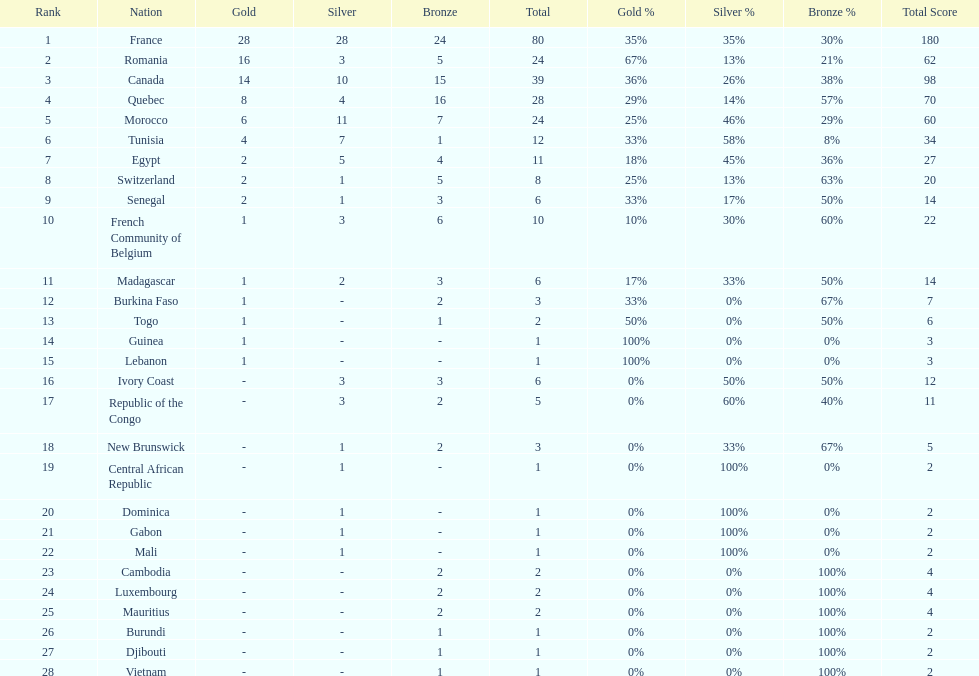Who placed in first according to medals? France. Would you mind parsing the complete table? {'header': ['Rank', 'Nation', 'Gold', 'Silver', 'Bronze', 'Total', 'Gold %', 'Silver %', 'Bronze %', 'Total Score'], 'rows': [['1', 'France', '28', '28', '24', '80', '35%', '35%', '30%', '180'], ['2', 'Romania', '16', '3', '5', '24', '67%', '13%', '21%', '62'], ['3', 'Canada', '14', '10', '15', '39', '36%', '26%', '38%', '98'], ['4', 'Quebec', '8', '4', '16', '28', '29%', '14%', '57%', '70'], ['5', 'Morocco', '6', '11', '7', '24', '25%', '46%', '29%', '60'], ['6', 'Tunisia', '4', '7', '1', '12', '33%', '58%', '8%', '34'], ['7', 'Egypt', '2', '5', '4', '11', '18%', '45%', '36%', '27'], ['8', 'Switzerland', '2', '1', '5', '8', '25%', '13%', '63%', '20'], ['9', 'Senegal', '2', '1', '3', '6', '33%', '17%', '50%', '14'], ['10', 'French Community of Belgium', '1', '3', '6', '10', '10%', '30%', '60%', '22'], ['11', 'Madagascar', '1', '2', '3', '6', '17%', '33%', '50%', '14'], ['12', 'Burkina Faso', '1', '-', '2', '3', '33%', '0%', '67%', '7'], ['13', 'Togo', '1', '-', '1', '2', '50%', '0%', '50%', '6'], ['14', 'Guinea', '1', '-', '-', '1', '100%', '0%', '0%', '3'], ['15', 'Lebanon', '1', '-', '-', '1', '100%', '0%', '0%', '3'], ['16', 'Ivory Coast', '-', '3', '3', '6', '0%', '50%', '50%', '12'], ['17', 'Republic of the Congo', '-', '3', '2', '5', '0%', '60%', '40%', '11'], ['18', 'New Brunswick', '-', '1', '2', '3', '0%', '33%', '67%', '5'], ['19', 'Central African Republic', '-', '1', '-', '1', '0%', '100%', '0%', '2'], ['20', 'Dominica', '-', '1', '-', '1', '0%', '100%', '0%', '2'], ['21', 'Gabon', '-', '1', '-', '1', '0%', '100%', '0%', '2'], ['22', 'Mali', '-', '1', '-', '1', '0%', '100%', '0%', '2'], ['23', 'Cambodia', '-', '-', '2', '2', '0%', '0%', '100%', '4'], ['24', 'Luxembourg', '-', '-', '2', '2', '0%', '0%', '100%', '4'], ['25', 'Mauritius', '-', '-', '2', '2', '0%', '0%', '100%', '4'], ['26', 'Burundi', '-', '-', '1', '1', '0%', '0%', '100%', '2'], ['27', 'Djibouti', '-', '-', '1', '1', '0%', '0%', '100%', '2'], ['28', 'Vietnam', '-', '-', '1', '1', '0%', '0%', '100%', '2']]} 